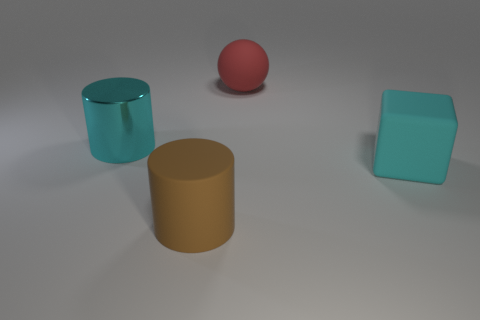The large cube has what color?
Offer a terse response. Cyan. There is a brown object; are there any cyan objects left of it?
Ensure brevity in your answer.  Yes. Is the color of the metallic object the same as the large matte cube?
Provide a succinct answer. Yes. What number of things have the same color as the big shiny cylinder?
Offer a terse response. 1. What size is the rubber thing behind the big cyan thing that is to the left of the big red matte sphere?
Your answer should be very brief. Large. The red object has what shape?
Give a very brief answer. Sphere. There is a object that is in front of the block; what is it made of?
Your answer should be very brief. Rubber. What color is the large rubber thing to the left of the large rubber object that is behind the big cylinder behind the brown object?
Keep it short and to the point. Brown. There is a ball that is the same size as the cyan rubber thing; what is its color?
Give a very brief answer. Red. How many metal objects are either big brown cylinders or red things?
Ensure brevity in your answer.  0. 